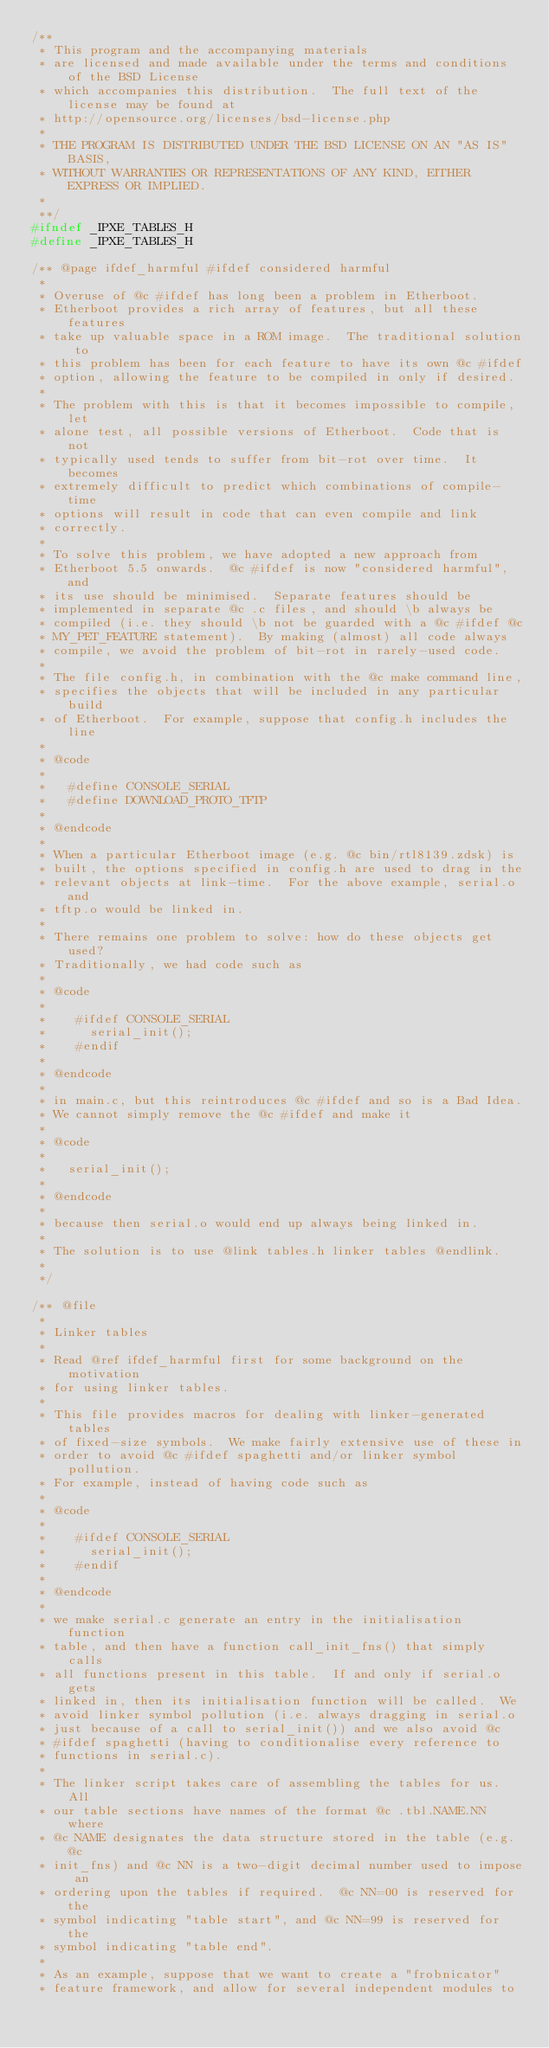<code> <loc_0><loc_0><loc_500><loc_500><_C_>/**
 * This program and the accompanying materials
 * are licensed and made available under the terms and conditions of the BSD License
 * which accompanies this distribution.  The full text of the license may be found at
 * http://opensource.org/licenses/bsd-license.php
 *
 * THE PROGRAM IS DISTRIBUTED UNDER THE BSD LICENSE ON AN "AS IS" BASIS,
 * WITHOUT WARRANTIES OR REPRESENTATIONS OF ANY KIND, EITHER EXPRESS OR IMPLIED.
 *
 **/
#ifndef _IPXE_TABLES_H
#define _IPXE_TABLES_H

/** @page ifdef_harmful #ifdef considered harmful
 *
 * Overuse of @c #ifdef has long been a problem in Etherboot.
 * Etherboot provides a rich array of features, but all these features
 * take up valuable space in a ROM image.  The traditional solution to
 * this problem has been for each feature to have its own @c #ifdef
 * option, allowing the feature to be compiled in only if desired.
 *
 * The problem with this is that it becomes impossible to compile, let
 * alone test, all possible versions of Etherboot.  Code that is not
 * typically used tends to suffer from bit-rot over time.  It becomes
 * extremely difficult to predict which combinations of compile-time
 * options will result in code that can even compile and link
 * correctly.
 *
 * To solve this problem, we have adopted a new approach from
 * Etherboot 5.5 onwards.  @c #ifdef is now "considered harmful", and
 * its use should be minimised.  Separate features should be
 * implemented in separate @c .c files, and should \b always be
 * compiled (i.e. they should \b not be guarded with a @c #ifdef @c
 * MY_PET_FEATURE statement).  By making (almost) all code always
 * compile, we avoid the problem of bit-rot in rarely-used code.
 *
 * The file config.h, in combination with the @c make command line,
 * specifies the objects that will be included in any particular build
 * of Etherboot.  For example, suppose that config.h includes the line
 *
 * @code
 *
 *   #define CONSOLE_SERIAL
 *   #define DOWNLOAD_PROTO_TFTP
 *
 * @endcode
 *
 * When a particular Etherboot image (e.g. @c bin/rtl8139.zdsk) is
 * built, the options specified in config.h are used to drag in the
 * relevant objects at link-time.  For the above example, serial.o and
 * tftp.o would be linked in.
 *
 * There remains one problem to solve: how do these objects get used?
 * Traditionally, we had code such as
 *
 * @code
 *
 *    #ifdef CONSOLE_SERIAL
 *      serial_init();
 *    #endif
 *
 * @endcode
 *
 * in main.c, but this reintroduces @c #ifdef and so is a Bad Idea.
 * We cannot simply remove the @c #ifdef and make it
 *
 * @code
 *
 *   serial_init();
 *
 * @endcode
 *
 * because then serial.o would end up always being linked in.
 *
 * The solution is to use @link tables.h linker tables @endlink.
 *
 */

/** @file
 *
 * Linker tables
 *
 * Read @ref ifdef_harmful first for some background on the motivation
 * for using linker tables.
 *
 * This file provides macros for dealing with linker-generated tables
 * of fixed-size symbols.  We make fairly extensive use of these in
 * order to avoid @c #ifdef spaghetti and/or linker symbol pollution.
 * For example, instead of having code such as
 *
 * @code
 *
 *    #ifdef CONSOLE_SERIAL
 *      serial_init();
 *    #endif
 *
 * @endcode
 *
 * we make serial.c generate an entry in the initialisation function
 * table, and then have a function call_init_fns() that simply calls
 * all functions present in this table.  If and only if serial.o gets
 * linked in, then its initialisation function will be called.  We
 * avoid linker symbol pollution (i.e. always dragging in serial.o
 * just because of a call to serial_init()) and we also avoid @c
 * #ifdef spaghetti (having to conditionalise every reference to
 * functions in serial.c).
 *
 * The linker script takes care of assembling the tables for us.  All
 * our table sections have names of the format @c .tbl.NAME.NN where
 * @c NAME designates the data structure stored in the table (e.g. @c
 * init_fns) and @c NN is a two-digit decimal number used to impose an
 * ordering upon the tables if required.  @c NN=00 is reserved for the
 * symbol indicating "table start", and @c NN=99 is reserved for the
 * symbol indicating "table end".
 *
 * As an example, suppose that we want to create a "frobnicator"
 * feature framework, and allow for several independent modules to</code> 